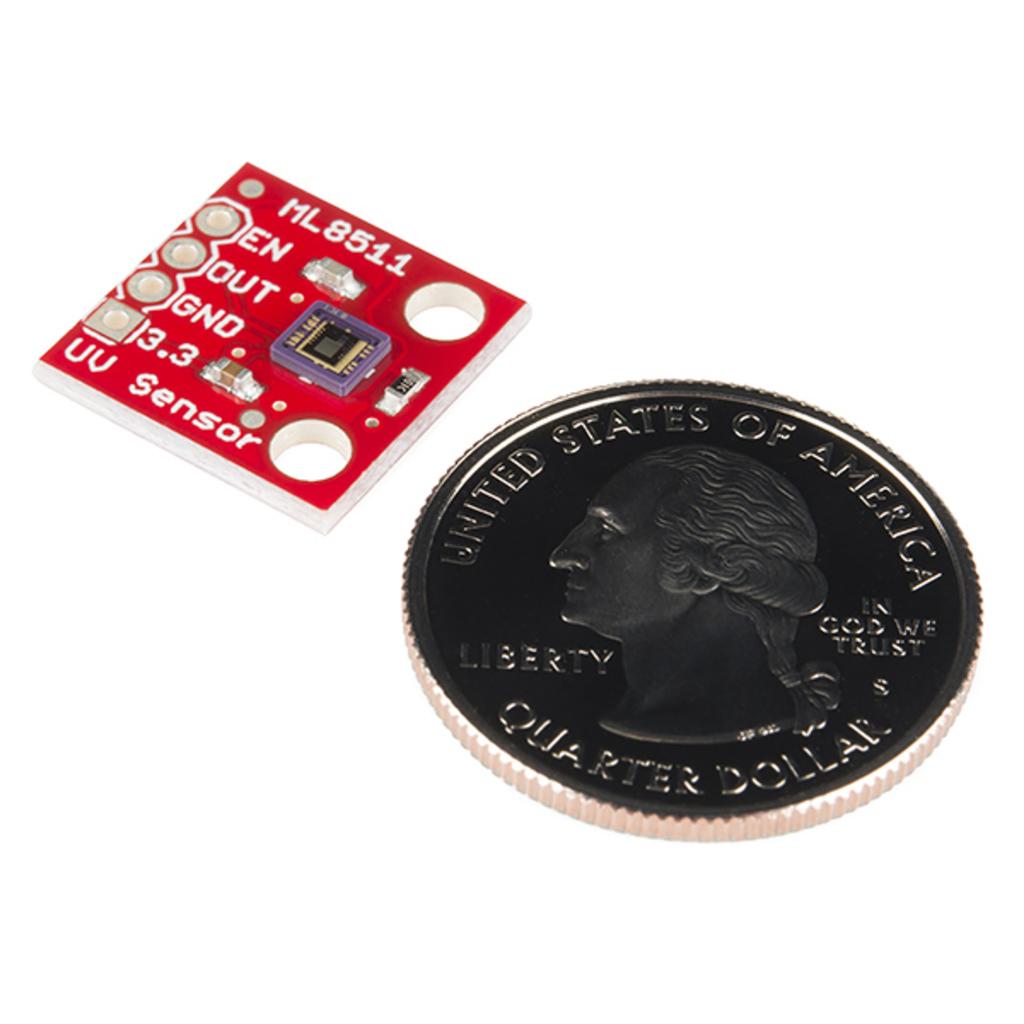How many dollars is that coin?
Provide a short and direct response. Quarter dollar. What country is the coin from?
Your answer should be very brief. United states of america. 